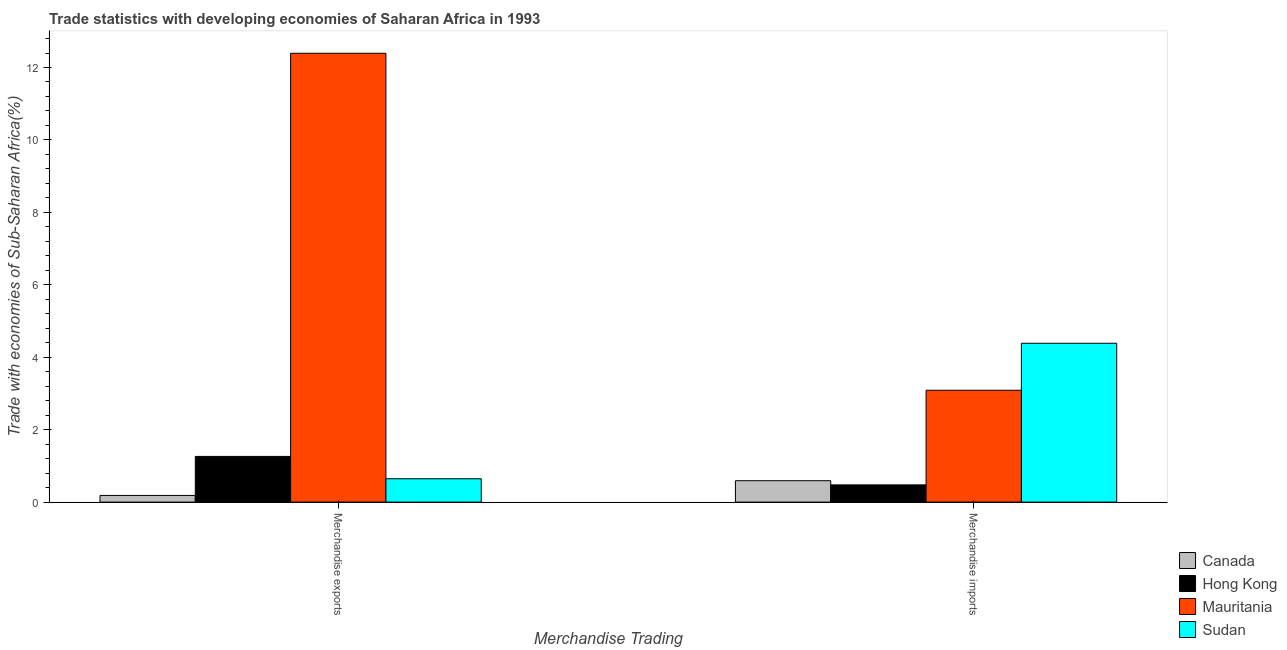How many bars are there on the 1st tick from the right?
Offer a terse response. 4. What is the label of the 2nd group of bars from the left?
Offer a very short reply. Merchandise imports. What is the merchandise imports in Hong Kong?
Give a very brief answer. 0.48. Across all countries, what is the maximum merchandise imports?
Offer a terse response. 4.39. Across all countries, what is the minimum merchandise exports?
Your answer should be compact. 0.18. In which country was the merchandise exports maximum?
Offer a terse response. Mauritania. In which country was the merchandise imports minimum?
Make the answer very short. Hong Kong. What is the total merchandise imports in the graph?
Your response must be concise. 8.54. What is the difference between the merchandise imports in Mauritania and that in Sudan?
Keep it short and to the point. -1.3. What is the difference between the merchandise exports in Canada and the merchandise imports in Hong Kong?
Provide a succinct answer. -0.29. What is the average merchandise imports per country?
Offer a very short reply. 2.14. What is the difference between the merchandise exports and merchandise imports in Mauritania?
Ensure brevity in your answer.  9.3. What is the ratio of the merchandise imports in Sudan to that in Mauritania?
Offer a very short reply. 1.42. Is the merchandise imports in Hong Kong less than that in Sudan?
Keep it short and to the point. Yes. In how many countries, is the merchandise exports greater than the average merchandise exports taken over all countries?
Your answer should be very brief. 1. What does the 2nd bar from the left in Merchandise imports represents?
Your answer should be compact. Hong Kong. What does the 2nd bar from the right in Merchandise exports represents?
Ensure brevity in your answer.  Mauritania. How many bars are there?
Make the answer very short. 8. Are all the bars in the graph horizontal?
Keep it short and to the point. No. Are the values on the major ticks of Y-axis written in scientific E-notation?
Make the answer very short. No. Does the graph contain any zero values?
Make the answer very short. No. Does the graph contain grids?
Your answer should be very brief. No. Where does the legend appear in the graph?
Offer a very short reply. Bottom right. How many legend labels are there?
Give a very brief answer. 4. What is the title of the graph?
Ensure brevity in your answer.  Trade statistics with developing economies of Saharan Africa in 1993. What is the label or title of the X-axis?
Keep it short and to the point. Merchandise Trading. What is the label or title of the Y-axis?
Provide a short and direct response. Trade with economies of Sub-Saharan Africa(%). What is the Trade with economies of Sub-Saharan Africa(%) of Canada in Merchandise exports?
Give a very brief answer. 0.18. What is the Trade with economies of Sub-Saharan Africa(%) in Hong Kong in Merchandise exports?
Your answer should be very brief. 1.26. What is the Trade with economies of Sub-Saharan Africa(%) in Mauritania in Merchandise exports?
Your answer should be very brief. 12.39. What is the Trade with economies of Sub-Saharan Africa(%) of Sudan in Merchandise exports?
Offer a very short reply. 0.65. What is the Trade with economies of Sub-Saharan Africa(%) in Canada in Merchandise imports?
Ensure brevity in your answer.  0.59. What is the Trade with economies of Sub-Saharan Africa(%) in Hong Kong in Merchandise imports?
Your response must be concise. 0.48. What is the Trade with economies of Sub-Saharan Africa(%) of Mauritania in Merchandise imports?
Provide a succinct answer. 3.09. What is the Trade with economies of Sub-Saharan Africa(%) of Sudan in Merchandise imports?
Offer a terse response. 4.39. Across all Merchandise Trading, what is the maximum Trade with economies of Sub-Saharan Africa(%) in Canada?
Your response must be concise. 0.59. Across all Merchandise Trading, what is the maximum Trade with economies of Sub-Saharan Africa(%) in Hong Kong?
Give a very brief answer. 1.26. Across all Merchandise Trading, what is the maximum Trade with economies of Sub-Saharan Africa(%) in Mauritania?
Ensure brevity in your answer.  12.39. Across all Merchandise Trading, what is the maximum Trade with economies of Sub-Saharan Africa(%) in Sudan?
Give a very brief answer. 4.39. Across all Merchandise Trading, what is the minimum Trade with economies of Sub-Saharan Africa(%) of Canada?
Your answer should be very brief. 0.18. Across all Merchandise Trading, what is the minimum Trade with economies of Sub-Saharan Africa(%) in Hong Kong?
Your response must be concise. 0.48. Across all Merchandise Trading, what is the minimum Trade with economies of Sub-Saharan Africa(%) in Mauritania?
Your answer should be very brief. 3.09. Across all Merchandise Trading, what is the minimum Trade with economies of Sub-Saharan Africa(%) of Sudan?
Keep it short and to the point. 0.65. What is the total Trade with economies of Sub-Saharan Africa(%) of Canada in the graph?
Offer a very short reply. 0.78. What is the total Trade with economies of Sub-Saharan Africa(%) in Hong Kong in the graph?
Your response must be concise. 1.74. What is the total Trade with economies of Sub-Saharan Africa(%) of Mauritania in the graph?
Your answer should be compact. 15.48. What is the total Trade with economies of Sub-Saharan Africa(%) in Sudan in the graph?
Make the answer very short. 5.03. What is the difference between the Trade with economies of Sub-Saharan Africa(%) in Canada in Merchandise exports and that in Merchandise imports?
Give a very brief answer. -0.41. What is the difference between the Trade with economies of Sub-Saharan Africa(%) of Hong Kong in Merchandise exports and that in Merchandise imports?
Your answer should be very brief. 0.79. What is the difference between the Trade with economies of Sub-Saharan Africa(%) of Mauritania in Merchandise exports and that in Merchandise imports?
Provide a succinct answer. 9.3. What is the difference between the Trade with economies of Sub-Saharan Africa(%) of Sudan in Merchandise exports and that in Merchandise imports?
Ensure brevity in your answer.  -3.74. What is the difference between the Trade with economies of Sub-Saharan Africa(%) of Canada in Merchandise exports and the Trade with economies of Sub-Saharan Africa(%) of Hong Kong in Merchandise imports?
Give a very brief answer. -0.29. What is the difference between the Trade with economies of Sub-Saharan Africa(%) in Canada in Merchandise exports and the Trade with economies of Sub-Saharan Africa(%) in Mauritania in Merchandise imports?
Your answer should be compact. -2.9. What is the difference between the Trade with economies of Sub-Saharan Africa(%) in Canada in Merchandise exports and the Trade with economies of Sub-Saharan Africa(%) in Sudan in Merchandise imports?
Provide a succinct answer. -4.2. What is the difference between the Trade with economies of Sub-Saharan Africa(%) in Hong Kong in Merchandise exports and the Trade with economies of Sub-Saharan Africa(%) in Mauritania in Merchandise imports?
Your answer should be compact. -1.83. What is the difference between the Trade with economies of Sub-Saharan Africa(%) in Hong Kong in Merchandise exports and the Trade with economies of Sub-Saharan Africa(%) in Sudan in Merchandise imports?
Ensure brevity in your answer.  -3.12. What is the difference between the Trade with economies of Sub-Saharan Africa(%) of Mauritania in Merchandise exports and the Trade with economies of Sub-Saharan Africa(%) of Sudan in Merchandise imports?
Offer a very short reply. 8.01. What is the average Trade with economies of Sub-Saharan Africa(%) in Canada per Merchandise Trading?
Your response must be concise. 0.39. What is the average Trade with economies of Sub-Saharan Africa(%) of Hong Kong per Merchandise Trading?
Offer a very short reply. 0.87. What is the average Trade with economies of Sub-Saharan Africa(%) in Mauritania per Merchandise Trading?
Offer a very short reply. 7.74. What is the average Trade with economies of Sub-Saharan Africa(%) of Sudan per Merchandise Trading?
Offer a terse response. 2.52. What is the difference between the Trade with economies of Sub-Saharan Africa(%) in Canada and Trade with economies of Sub-Saharan Africa(%) in Hong Kong in Merchandise exports?
Make the answer very short. -1.08. What is the difference between the Trade with economies of Sub-Saharan Africa(%) in Canada and Trade with economies of Sub-Saharan Africa(%) in Mauritania in Merchandise exports?
Your answer should be very brief. -12.21. What is the difference between the Trade with economies of Sub-Saharan Africa(%) in Canada and Trade with economies of Sub-Saharan Africa(%) in Sudan in Merchandise exports?
Offer a terse response. -0.46. What is the difference between the Trade with economies of Sub-Saharan Africa(%) of Hong Kong and Trade with economies of Sub-Saharan Africa(%) of Mauritania in Merchandise exports?
Your answer should be compact. -11.13. What is the difference between the Trade with economies of Sub-Saharan Africa(%) of Hong Kong and Trade with economies of Sub-Saharan Africa(%) of Sudan in Merchandise exports?
Provide a succinct answer. 0.62. What is the difference between the Trade with economies of Sub-Saharan Africa(%) of Mauritania and Trade with economies of Sub-Saharan Africa(%) of Sudan in Merchandise exports?
Your answer should be compact. 11.75. What is the difference between the Trade with economies of Sub-Saharan Africa(%) of Canada and Trade with economies of Sub-Saharan Africa(%) of Hong Kong in Merchandise imports?
Provide a succinct answer. 0.11. What is the difference between the Trade with economies of Sub-Saharan Africa(%) of Canada and Trade with economies of Sub-Saharan Africa(%) of Mauritania in Merchandise imports?
Give a very brief answer. -2.5. What is the difference between the Trade with economies of Sub-Saharan Africa(%) in Canada and Trade with economies of Sub-Saharan Africa(%) in Sudan in Merchandise imports?
Offer a very short reply. -3.79. What is the difference between the Trade with economies of Sub-Saharan Africa(%) of Hong Kong and Trade with economies of Sub-Saharan Africa(%) of Mauritania in Merchandise imports?
Your response must be concise. -2.61. What is the difference between the Trade with economies of Sub-Saharan Africa(%) in Hong Kong and Trade with economies of Sub-Saharan Africa(%) in Sudan in Merchandise imports?
Offer a very short reply. -3.91. What is the difference between the Trade with economies of Sub-Saharan Africa(%) in Mauritania and Trade with economies of Sub-Saharan Africa(%) in Sudan in Merchandise imports?
Make the answer very short. -1.3. What is the ratio of the Trade with economies of Sub-Saharan Africa(%) in Canada in Merchandise exports to that in Merchandise imports?
Keep it short and to the point. 0.31. What is the ratio of the Trade with economies of Sub-Saharan Africa(%) in Hong Kong in Merchandise exports to that in Merchandise imports?
Offer a terse response. 2.65. What is the ratio of the Trade with economies of Sub-Saharan Africa(%) in Mauritania in Merchandise exports to that in Merchandise imports?
Offer a very short reply. 4.01. What is the ratio of the Trade with economies of Sub-Saharan Africa(%) in Sudan in Merchandise exports to that in Merchandise imports?
Your answer should be compact. 0.15. What is the difference between the highest and the second highest Trade with economies of Sub-Saharan Africa(%) in Canada?
Provide a succinct answer. 0.41. What is the difference between the highest and the second highest Trade with economies of Sub-Saharan Africa(%) in Hong Kong?
Ensure brevity in your answer.  0.79. What is the difference between the highest and the second highest Trade with economies of Sub-Saharan Africa(%) in Mauritania?
Offer a very short reply. 9.3. What is the difference between the highest and the second highest Trade with economies of Sub-Saharan Africa(%) in Sudan?
Your response must be concise. 3.74. What is the difference between the highest and the lowest Trade with economies of Sub-Saharan Africa(%) of Canada?
Offer a very short reply. 0.41. What is the difference between the highest and the lowest Trade with economies of Sub-Saharan Africa(%) in Hong Kong?
Your answer should be very brief. 0.79. What is the difference between the highest and the lowest Trade with economies of Sub-Saharan Africa(%) in Mauritania?
Your response must be concise. 9.3. What is the difference between the highest and the lowest Trade with economies of Sub-Saharan Africa(%) in Sudan?
Your answer should be very brief. 3.74. 